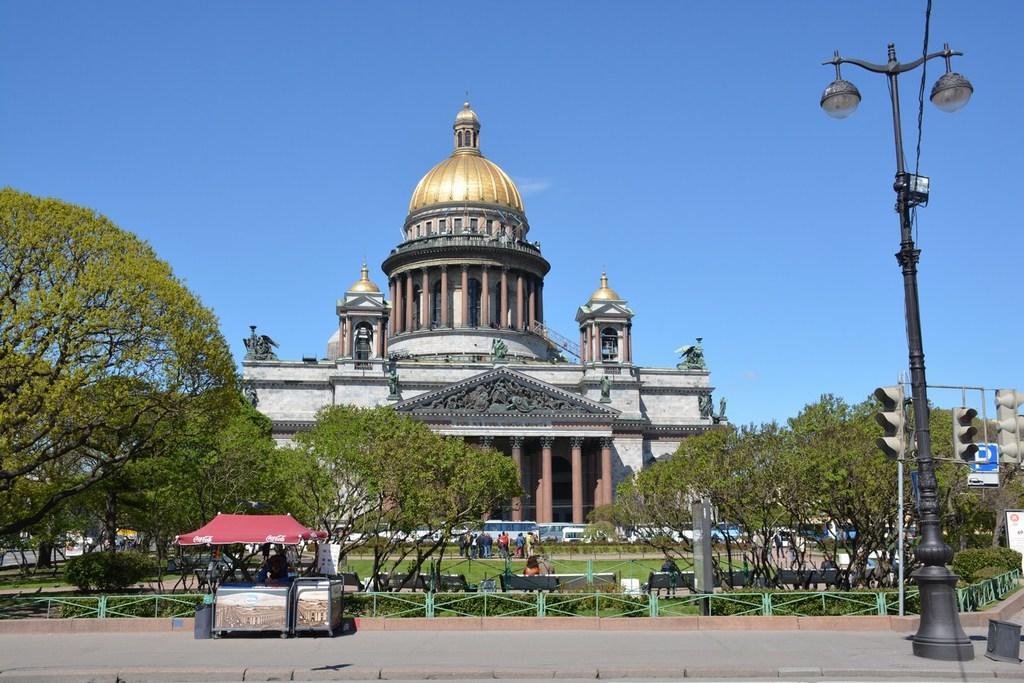How would you summarize this image in a sentence or two? At the bottom of the picture, we see the road. Beside that, we see a table which is placed under the red tent. Beside that, we see a garbage bin and a board in white color with some text written on it. Behind that, we see the railing and the shrubs. On the right side, we see the streetlights and the traffic signals. Beside that, we see the board in the white and blue color. Behind that, we see the trees and the people are sitting on the benches. On the left side, we see the trees. In the middle, we see the people are standing. In front of them, we see the vehicles. In the background, we see a building which is named as Saint Petersburg. In the background, we see the sky, which is blue in color. 